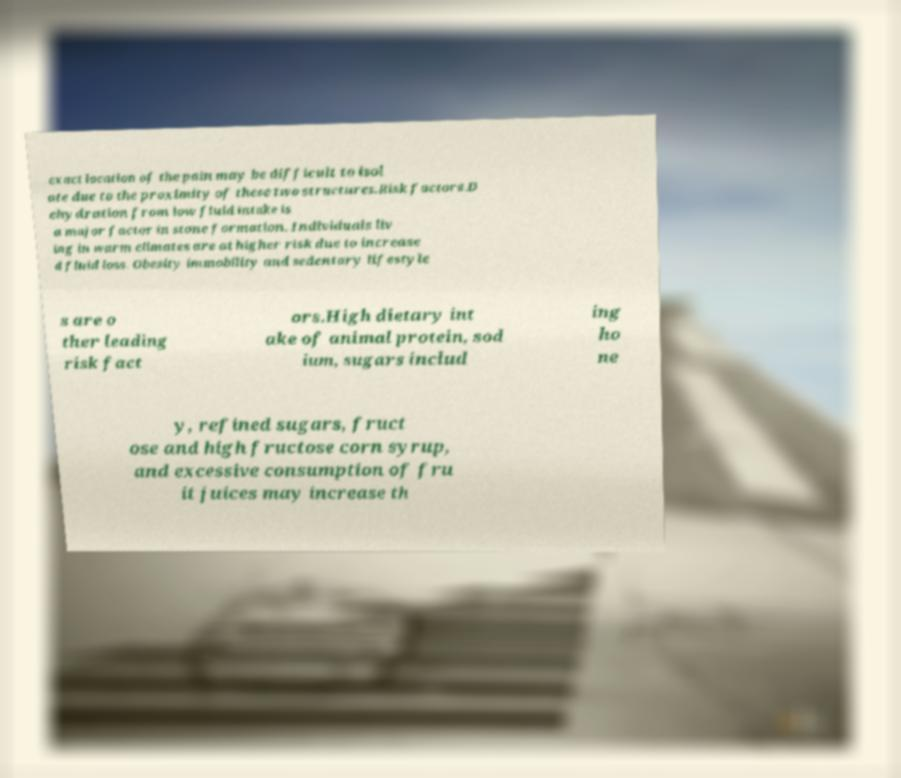Can you read and provide the text displayed in the image?This photo seems to have some interesting text. Can you extract and type it out for me? exact location of the pain may be difficult to isol ate due to the proximity of these two structures.Risk factors.D ehydration from low fluid intake is a major factor in stone formation. Individuals liv ing in warm climates are at higher risk due to increase d fluid loss. Obesity immobility and sedentary lifestyle s are o ther leading risk fact ors.High dietary int ake of animal protein, sod ium, sugars includ ing ho ne y, refined sugars, fruct ose and high fructose corn syrup, and excessive consumption of fru it juices may increase th 